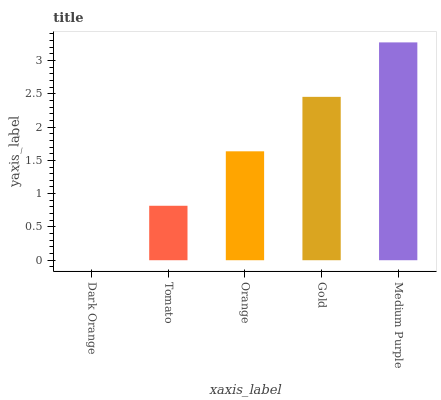Is Dark Orange the minimum?
Answer yes or no. Yes. Is Medium Purple the maximum?
Answer yes or no. Yes. Is Tomato the minimum?
Answer yes or no. No. Is Tomato the maximum?
Answer yes or no. No. Is Tomato greater than Dark Orange?
Answer yes or no. Yes. Is Dark Orange less than Tomato?
Answer yes or no. Yes. Is Dark Orange greater than Tomato?
Answer yes or no. No. Is Tomato less than Dark Orange?
Answer yes or no. No. Is Orange the high median?
Answer yes or no. Yes. Is Orange the low median?
Answer yes or no. Yes. Is Dark Orange the high median?
Answer yes or no. No. Is Gold the low median?
Answer yes or no. No. 